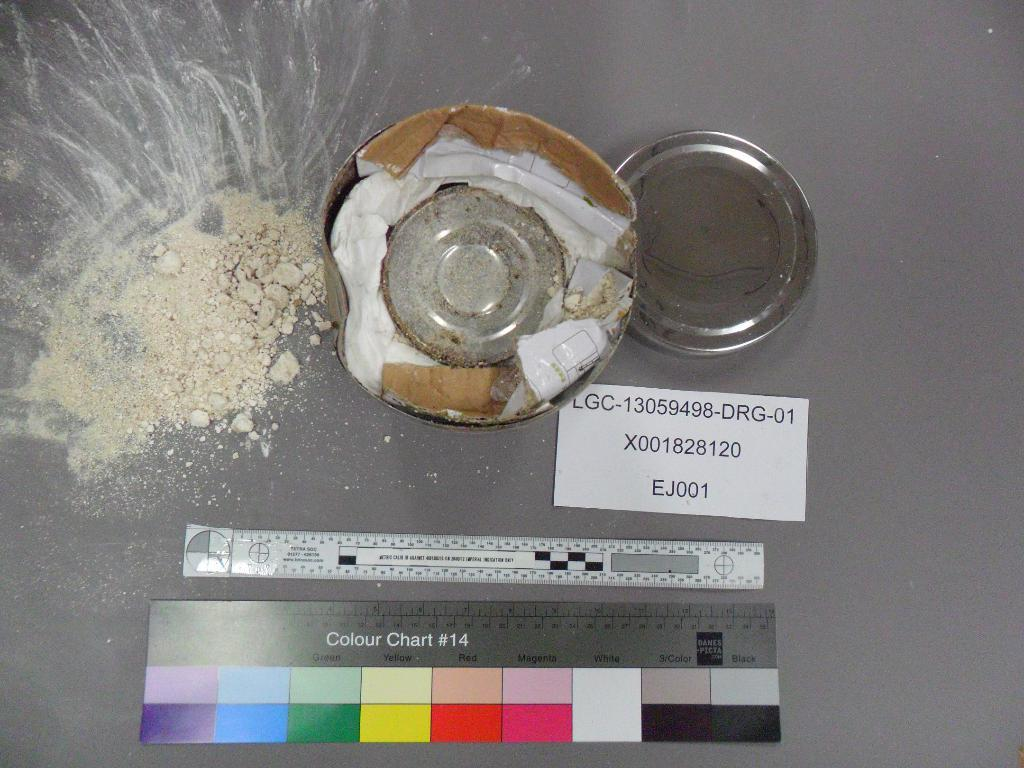<image>
Render a clear and concise summary of the photo. a can with a colour chart #14 shown below it 